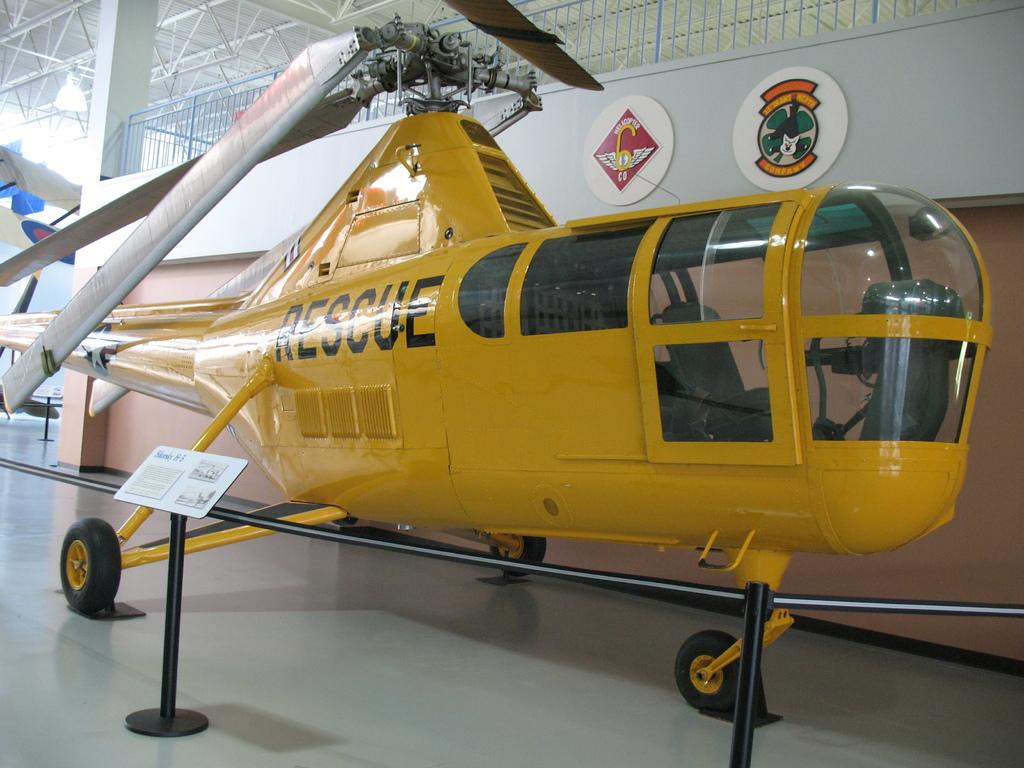<image>
Render a clear and concise summary of the photo. A resuce plane parked inside of a building. 